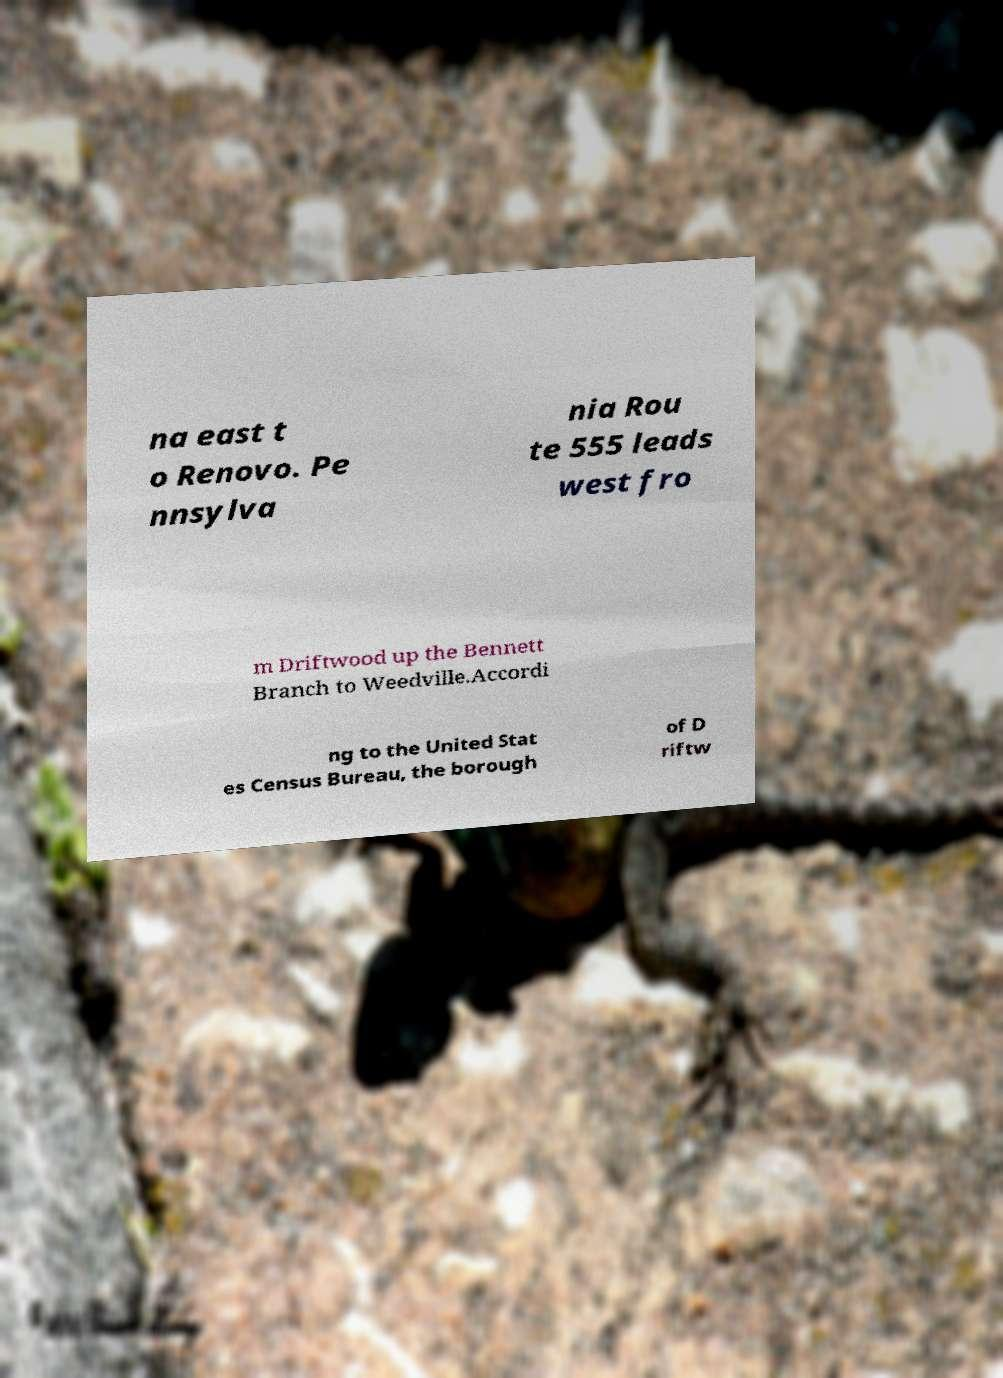Can you read and provide the text displayed in the image?This photo seems to have some interesting text. Can you extract and type it out for me? na east t o Renovo. Pe nnsylva nia Rou te 555 leads west fro m Driftwood up the Bennett Branch to Weedville.Accordi ng to the United Stat es Census Bureau, the borough of D riftw 